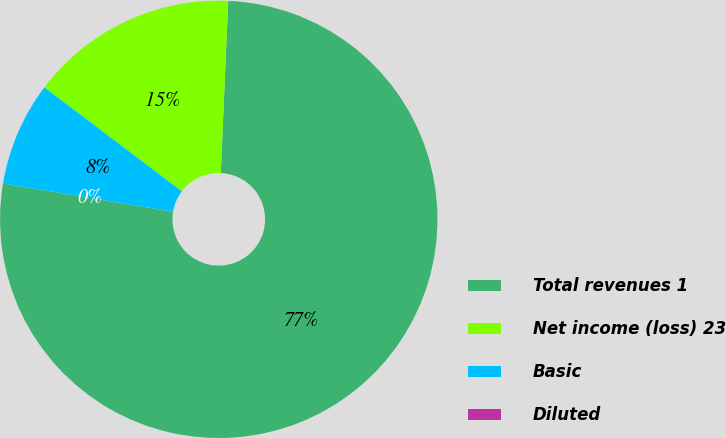Convert chart. <chart><loc_0><loc_0><loc_500><loc_500><pie_chart><fcel>Total revenues 1<fcel>Net income (loss) 23<fcel>Basic<fcel>Diluted<nl><fcel>76.92%<fcel>15.38%<fcel>7.69%<fcel>0.0%<nl></chart> 